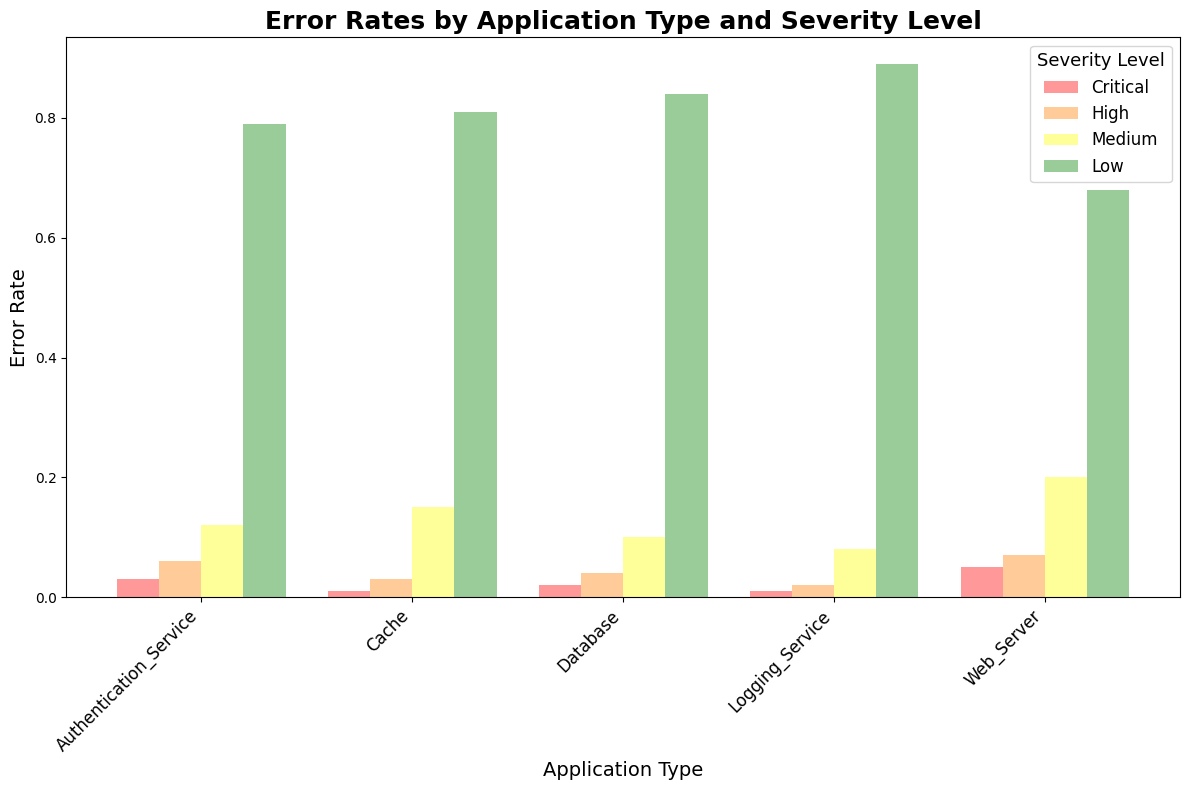What is the application type with the highest overall error rate? To find the application type with the highest overall error rate, we need to compare the sum of error rates across all severity levels for each application type. Summing the error rates, the Web Server has 1.0, Database has 1.0, Cache has 1.0, Authentication_Service has 1.0, and Logging_Service has 1.0. All application types have the same overall error rate, therefore, there isn't a single application type with the highest error rate.
Answer: All application types Which severity level has the highest error rate for the Logging_Service? To determine the highest error rate for the Logging_Service, we look at the bar heights for each severity level: Critical (0.01), High (0.02), Medium (0.08), and Low (0.89). The tallest bar corresponds to the Low severity level.
Answer: Low Which application type has the lowest error rate for Critical severity level? To find the application type with the lowest error rate for Critical severity level, we compare the heights of the Critical severity bars. Web_Server (0.05), Database (0.02), Cache (0.01), Authentication_Service (0.03), and Logging_Service (0.01). Both Cache and Logging_Service have the lowest error rate of 0.01.
Answer: Cache and Logging_Service How much higher is the Low error rate for Database compared to the Medium error rate for Database? To find the difference, we subtract the Medium severity error rate from the Low severity error rate for the Database. The Low severity error rate is 0.84 and the Medium severity error rate is 0.1. So, 0.84 - 0.1 = 0.74.
Answer: 0.74 Which application type has the smallest difference between High and Medium severity error rates? To solve this, we subtract the Medium severity error rate from the High severity level for each application type and find the smallest difference: 
Web_Server: 0.07-0.2=-0.13 
Database: 0.04-0.1=-0.06 
Cache: 0.03-0.15=-0.12
Authentication_Service: 0.06-0.12=-0.06 
Logging_Service: 0.02-0.08=-0.06. 
Therefore, Database, Authentication_Service, and Logging_Service all have the smallest difference of -0.06.
Answer: Database, Authentication_Service, Logging_Service Which severity level has the least variability across all application types? We look at how the heights of each level's bars vary across application types. The Critical severity levels for all application types hover close to the same low value (Web_Server: 0.05, Database: 0.02, Cache: 0.01, Authentication_Service: 0.03, Logging_Service: 0.01), making Critical the level with the least variability.
Answer: Critical How does the error rate of the Web_Server for Medium severity compare to that of the Cache for Medium severity? We compare the bar heights for Medium severity between Web_Server and Cache. The error rate for Web_Server is 0.2 and for Cache is 0.15. Therefore, the Web_Server Medium severity error rate is higher by 0.2 - 0.15 = 0.05.
Answer: Web_Server's Medium severity error rate is higher by 0.05 